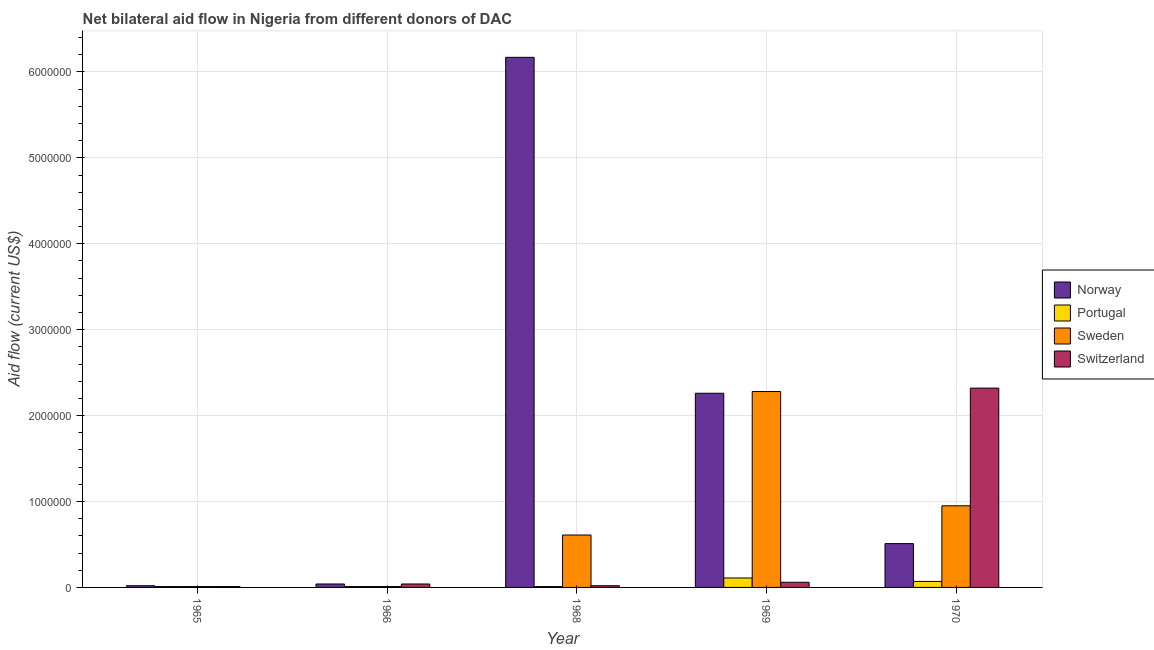How many groups of bars are there?
Your response must be concise. 5. How many bars are there on the 1st tick from the left?
Provide a succinct answer. 4. How many bars are there on the 4th tick from the right?
Provide a succinct answer. 4. What is the label of the 4th group of bars from the left?
Give a very brief answer. 1969. In how many cases, is the number of bars for a given year not equal to the number of legend labels?
Ensure brevity in your answer.  0. What is the amount of aid given by switzerland in 1970?
Provide a short and direct response. 2.32e+06. Across all years, what is the maximum amount of aid given by portugal?
Offer a very short reply. 1.10e+05. Across all years, what is the minimum amount of aid given by portugal?
Ensure brevity in your answer.  10000. In which year was the amount of aid given by sweden minimum?
Keep it short and to the point. 1965. What is the total amount of aid given by sweden in the graph?
Provide a short and direct response. 3.86e+06. What is the difference between the amount of aid given by switzerland in 1965 and that in 1966?
Keep it short and to the point. -3.00e+04. What is the difference between the amount of aid given by switzerland in 1969 and the amount of aid given by norway in 1968?
Your answer should be compact. 4.00e+04. In how many years, is the amount of aid given by sweden greater than 3600000 US$?
Offer a very short reply. 0. What is the difference between the highest and the second highest amount of aid given by sweden?
Your answer should be very brief. 1.33e+06. What is the difference between the highest and the lowest amount of aid given by portugal?
Keep it short and to the point. 1.00e+05. In how many years, is the amount of aid given by norway greater than the average amount of aid given by norway taken over all years?
Make the answer very short. 2. Is it the case that in every year, the sum of the amount of aid given by norway and amount of aid given by sweden is greater than the sum of amount of aid given by switzerland and amount of aid given by portugal?
Keep it short and to the point. Yes. What does the 1st bar from the left in 1965 represents?
Make the answer very short. Norway. What does the 3rd bar from the right in 1966 represents?
Ensure brevity in your answer.  Portugal. Is it the case that in every year, the sum of the amount of aid given by norway and amount of aid given by portugal is greater than the amount of aid given by sweden?
Ensure brevity in your answer.  No. How many bars are there?
Give a very brief answer. 20. Are all the bars in the graph horizontal?
Your response must be concise. No. Does the graph contain any zero values?
Your answer should be compact. No. Does the graph contain grids?
Provide a succinct answer. Yes. Where does the legend appear in the graph?
Offer a very short reply. Center right. How are the legend labels stacked?
Keep it short and to the point. Vertical. What is the title of the graph?
Your answer should be compact. Net bilateral aid flow in Nigeria from different donors of DAC. What is the label or title of the X-axis?
Your response must be concise. Year. What is the label or title of the Y-axis?
Give a very brief answer. Aid flow (current US$). What is the Aid flow (current US$) in Portugal in 1965?
Make the answer very short. 10000. What is the Aid flow (current US$) in Norway in 1966?
Offer a terse response. 4.00e+04. What is the Aid flow (current US$) of Portugal in 1966?
Your answer should be very brief. 10000. What is the Aid flow (current US$) of Sweden in 1966?
Ensure brevity in your answer.  10000. What is the Aid flow (current US$) in Switzerland in 1966?
Your response must be concise. 4.00e+04. What is the Aid flow (current US$) in Norway in 1968?
Offer a very short reply. 6.17e+06. What is the Aid flow (current US$) of Portugal in 1968?
Your answer should be compact. 10000. What is the Aid flow (current US$) of Sweden in 1968?
Make the answer very short. 6.10e+05. What is the Aid flow (current US$) of Switzerland in 1968?
Provide a succinct answer. 2.00e+04. What is the Aid flow (current US$) of Norway in 1969?
Give a very brief answer. 2.26e+06. What is the Aid flow (current US$) in Sweden in 1969?
Your response must be concise. 2.28e+06. What is the Aid flow (current US$) in Switzerland in 1969?
Your response must be concise. 6.00e+04. What is the Aid flow (current US$) in Norway in 1970?
Your response must be concise. 5.10e+05. What is the Aid flow (current US$) of Sweden in 1970?
Give a very brief answer. 9.50e+05. What is the Aid flow (current US$) in Switzerland in 1970?
Ensure brevity in your answer.  2.32e+06. Across all years, what is the maximum Aid flow (current US$) of Norway?
Your answer should be compact. 6.17e+06. Across all years, what is the maximum Aid flow (current US$) of Sweden?
Provide a short and direct response. 2.28e+06. Across all years, what is the maximum Aid flow (current US$) in Switzerland?
Your answer should be compact. 2.32e+06. Across all years, what is the minimum Aid flow (current US$) of Norway?
Your answer should be very brief. 2.00e+04. Across all years, what is the minimum Aid flow (current US$) in Portugal?
Offer a terse response. 10000. Across all years, what is the minimum Aid flow (current US$) in Sweden?
Provide a succinct answer. 10000. What is the total Aid flow (current US$) in Norway in the graph?
Your answer should be very brief. 9.00e+06. What is the total Aid flow (current US$) of Sweden in the graph?
Make the answer very short. 3.86e+06. What is the total Aid flow (current US$) in Switzerland in the graph?
Ensure brevity in your answer.  2.45e+06. What is the difference between the Aid flow (current US$) of Portugal in 1965 and that in 1966?
Keep it short and to the point. 0. What is the difference between the Aid flow (current US$) in Sweden in 1965 and that in 1966?
Your answer should be very brief. 0. What is the difference between the Aid flow (current US$) of Norway in 1965 and that in 1968?
Your response must be concise. -6.15e+06. What is the difference between the Aid flow (current US$) in Portugal in 1965 and that in 1968?
Offer a very short reply. 0. What is the difference between the Aid flow (current US$) in Sweden in 1965 and that in 1968?
Offer a terse response. -6.00e+05. What is the difference between the Aid flow (current US$) in Norway in 1965 and that in 1969?
Offer a terse response. -2.24e+06. What is the difference between the Aid flow (current US$) of Sweden in 1965 and that in 1969?
Your response must be concise. -2.27e+06. What is the difference between the Aid flow (current US$) of Norway in 1965 and that in 1970?
Ensure brevity in your answer.  -4.90e+05. What is the difference between the Aid flow (current US$) of Sweden in 1965 and that in 1970?
Your response must be concise. -9.40e+05. What is the difference between the Aid flow (current US$) of Switzerland in 1965 and that in 1970?
Ensure brevity in your answer.  -2.31e+06. What is the difference between the Aid flow (current US$) of Norway in 1966 and that in 1968?
Offer a very short reply. -6.13e+06. What is the difference between the Aid flow (current US$) of Sweden in 1966 and that in 1968?
Your answer should be very brief. -6.00e+05. What is the difference between the Aid flow (current US$) in Switzerland in 1966 and that in 1968?
Your answer should be very brief. 2.00e+04. What is the difference between the Aid flow (current US$) of Norway in 1966 and that in 1969?
Offer a terse response. -2.22e+06. What is the difference between the Aid flow (current US$) in Sweden in 1966 and that in 1969?
Provide a succinct answer. -2.27e+06. What is the difference between the Aid flow (current US$) in Switzerland in 1966 and that in 1969?
Keep it short and to the point. -2.00e+04. What is the difference between the Aid flow (current US$) in Norway in 1966 and that in 1970?
Make the answer very short. -4.70e+05. What is the difference between the Aid flow (current US$) of Portugal in 1966 and that in 1970?
Your answer should be very brief. -6.00e+04. What is the difference between the Aid flow (current US$) in Sweden in 1966 and that in 1970?
Keep it short and to the point. -9.40e+05. What is the difference between the Aid flow (current US$) in Switzerland in 1966 and that in 1970?
Make the answer very short. -2.28e+06. What is the difference between the Aid flow (current US$) of Norway in 1968 and that in 1969?
Make the answer very short. 3.91e+06. What is the difference between the Aid flow (current US$) in Sweden in 1968 and that in 1969?
Make the answer very short. -1.67e+06. What is the difference between the Aid flow (current US$) of Norway in 1968 and that in 1970?
Make the answer very short. 5.66e+06. What is the difference between the Aid flow (current US$) of Portugal in 1968 and that in 1970?
Make the answer very short. -6.00e+04. What is the difference between the Aid flow (current US$) of Sweden in 1968 and that in 1970?
Give a very brief answer. -3.40e+05. What is the difference between the Aid flow (current US$) in Switzerland in 1968 and that in 1970?
Give a very brief answer. -2.30e+06. What is the difference between the Aid flow (current US$) of Norway in 1969 and that in 1970?
Offer a very short reply. 1.75e+06. What is the difference between the Aid flow (current US$) in Sweden in 1969 and that in 1970?
Ensure brevity in your answer.  1.33e+06. What is the difference between the Aid flow (current US$) in Switzerland in 1969 and that in 1970?
Offer a very short reply. -2.26e+06. What is the difference between the Aid flow (current US$) in Norway in 1965 and the Aid flow (current US$) in Portugal in 1966?
Keep it short and to the point. 10000. What is the difference between the Aid flow (current US$) of Portugal in 1965 and the Aid flow (current US$) of Sweden in 1966?
Your response must be concise. 0. What is the difference between the Aid flow (current US$) of Sweden in 1965 and the Aid flow (current US$) of Switzerland in 1966?
Your answer should be very brief. -3.00e+04. What is the difference between the Aid flow (current US$) in Norway in 1965 and the Aid flow (current US$) in Portugal in 1968?
Your answer should be very brief. 10000. What is the difference between the Aid flow (current US$) in Norway in 1965 and the Aid flow (current US$) in Sweden in 1968?
Your answer should be very brief. -5.90e+05. What is the difference between the Aid flow (current US$) of Norway in 1965 and the Aid flow (current US$) of Switzerland in 1968?
Provide a succinct answer. 0. What is the difference between the Aid flow (current US$) of Portugal in 1965 and the Aid flow (current US$) of Sweden in 1968?
Keep it short and to the point. -6.00e+05. What is the difference between the Aid flow (current US$) of Norway in 1965 and the Aid flow (current US$) of Portugal in 1969?
Your answer should be very brief. -9.00e+04. What is the difference between the Aid flow (current US$) in Norway in 1965 and the Aid flow (current US$) in Sweden in 1969?
Make the answer very short. -2.26e+06. What is the difference between the Aid flow (current US$) in Norway in 1965 and the Aid flow (current US$) in Switzerland in 1969?
Your answer should be very brief. -4.00e+04. What is the difference between the Aid flow (current US$) in Portugal in 1965 and the Aid flow (current US$) in Sweden in 1969?
Your answer should be very brief. -2.27e+06. What is the difference between the Aid flow (current US$) of Sweden in 1965 and the Aid flow (current US$) of Switzerland in 1969?
Provide a short and direct response. -5.00e+04. What is the difference between the Aid flow (current US$) in Norway in 1965 and the Aid flow (current US$) in Portugal in 1970?
Your answer should be very brief. -5.00e+04. What is the difference between the Aid flow (current US$) in Norway in 1965 and the Aid flow (current US$) in Sweden in 1970?
Your answer should be very brief. -9.30e+05. What is the difference between the Aid flow (current US$) in Norway in 1965 and the Aid flow (current US$) in Switzerland in 1970?
Give a very brief answer. -2.30e+06. What is the difference between the Aid flow (current US$) in Portugal in 1965 and the Aid flow (current US$) in Sweden in 1970?
Keep it short and to the point. -9.40e+05. What is the difference between the Aid flow (current US$) of Portugal in 1965 and the Aid flow (current US$) of Switzerland in 1970?
Offer a very short reply. -2.31e+06. What is the difference between the Aid flow (current US$) of Sweden in 1965 and the Aid flow (current US$) of Switzerland in 1970?
Ensure brevity in your answer.  -2.31e+06. What is the difference between the Aid flow (current US$) of Norway in 1966 and the Aid flow (current US$) of Sweden in 1968?
Provide a short and direct response. -5.70e+05. What is the difference between the Aid flow (current US$) of Portugal in 1966 and the Aid flow (current US$) of Sweden in 1968?
Provide a short and direct response. -6.00e+05. What is the difference between the Aid flow (current US$) of Sweden in 1966 and the Aid flow (current US$) of Switzerland in 1968?
Provide a succinct answer. -10000. What is the difference between the Aid flow (current US$) in Norway in 1966 and the Aid flow (current US$) in Sweden in 1969?
Provide a short and direct response. -2.24e+06. What is the difference between the Aid flow (current US$) in Portugal in 1966 and the Aid flow (current US$) in Sweden in 1969?
Make the answer very short. -2.27e+06. What is the difference between the Aid flow (current US$) in Sweden in 1966 and the Aid flow (current US$) in Switzerland in 1969?
Your response must be concise. -5.00e+04. What is the difference between the Aid flow (current US$) in Norway in 1966 and the Aid flow (current US$) in Portugal in 1970?
Offer a very short reply. -3.00e+04. What is the difference between the Aid flow (current US$) in Norway in 1966 and the Aid flow (current US$) in Sweden in 1970?
Offer a very short reply. -9.10e+05. What is the difference between the Aid flow (current US$) in Norway in 1966 and the Aid flow (current US$) in Switzerland in 1970?
Make the answer very short. -2.28e+06. What is the difference between the Aid flow (current US$) in Portugal in 1966 and the Aid flow (current US$) in Sweden in 1970?
Offer a terse response. -9.40e+05. What is the difference between the Aid flow (current US$) in Portugal in 1966 and the Aid flow (current US$) in Switzerland in 1970?
Keep it short and to the point. -2.31e+06. What is the difference between the Aid flow (current US$) of Sweden in 1966 and the Aid flow (current US$) of Switzerland in 1970?
Your answer should be very brief. -2.31e+06. What is the difference between the Aid flow (current US$) in Norway in 1968 and the Aid flow (current US$) in Portugal in 1969?
Offer a very short reply. 6.06e+06. What is the difference between the Aid flow (current US$) in Norway in 1968 and the Aid flow (current US$) in Sweden in 1969?
Your answer should be compact. 3.89e+06. What is the difference between the Aid flow (current US$) of Norway in 1968 and the Aid flow (current US$) of Switzerland in 1969?
Provide a short and direct response. 6.11e+06. What is the difference between the Aid flow (current US$) of Portugal in 1968 and the Aid flow (current US$) of Sweden in 1969?
Your answer should be very brief. -2.27e+06. What is the difference between the Aid flow (current US$) in Portugal in 1968 and the Aid flow (current US$) in Switzerland in 1969?
Offer a very short reply. -5.00e+04. What is the difference between the Aid flow (current US$) of Sweden in 1968 and the Aid flow (current US$) of Switzerland in 1969?
Give a very brief answer. 5.50e+05. What is the difference between the Aid flow (current US$) of Norway in 1968 and the Aid flow (current US$) of Portugal in 1970?
Your response must be concise. 6.10e+06. What is the difference between the Aid flow (current US$) in Norway in 1968 and the Aid flow (current US$) in Sweden in 1970?
Your answer should be compact. 5.22e+06. What is the difference between the Aid flow (current US$) of Norway in 1968 and the Aid flow (current US$) of Switzerland in 1970?
Keep it short and to the point. 3.85e+06. What is the difference between the Aid flow (current US$) in Portugal in 1968 and the Aid flow (current US$) in Sweden in 1970?
Your answer should be very brief. -9.40e+05. What is the difference between the Aid flow (current US$) of Portugal in 1968 and the Aid flow (current US$) of Switzerland in 1970?
Your answer should be compact. -2.31e+06. What is the difference between the Aid flow (current US$) of Sweden in 1968 and the Aid flow (current US$) of Switzerland in 1970?
Give a very brief answer. -1.71e+06. What is the difference between the Aid flow (current US$) of Norway in 1969 and the Aid flow (current US$) of Portugal in 1970?
Make the answer very short. 2.19e+06. What is the difference between the Aid flow (current US$) in Norway in 1969 and the Aid flow (current US$) in Sweden in 1970?
Provide a short and direct response. 1.31e+06. What is the difference between the Aid flow (current US$) of Norway in 1969 and the Aid flow (current US$) of Switzerland in 1970?
Provide a succinct answer. -6.00e+04. What is the difference between the Aid flow (current US$) in Portugal in 1969 and the Aid flow (current US$) in Sweden in 1970?
Give a very brief answer. -8.40e+05. What is the difference between the Aid flow (current US$) of Portugal in 1969 and the Aid flow (current US$) of Switzerland in 1970?
Your answer should be very brief. -2.21e+06. What is the average Aid flow (current US$) in Norway per year?
Your response must be concise. 1.80e+06. What is the average Aid flow (current US$) in Portugal per year?
Your answer should be compact. 4.20e+04. What is the average Aid flow (current US$) of Sweden per year?
Provide a succinct answer. 7.72e+05. In the year 1965, what is the difference between the Aid flow (current US$) of Norway and Aid flow (current US$) of Sweden?
Provide a succinct answer. 10000. In the year 1965, what is the difference between the Aid flow (current US$) in Portugal and Aid flow (current US$) in Sweden?
Your answer should be very brief. 0. In the year 1965, what is the difference between the Aid flow (current US$) in Sweden and Aid flow (current US$) in Switzerland?
Your response must be concise. 0. In the year 1966, what is the difference between the Aid flow (current US$) of Norway and Aid flow (current US$) of Portugal?
Your response must be concise. 3.00e+04. In the year 1966, what is the difference between the Aid flow (current US$) of Norway and Aid flow (current US$) of Sweden?
Give a very brief answer. 3.00e+04. In the year 1966, what is the difference between the Aid flow (current US$) of Sweden and Aid flow (current US$) of Switzerland?
Your answer should be compact. -3.00e+04. In the year 1968, what is the difference between the Aid flow (current US$) in Norway and Aid flow (current US$) in Portugal?
Offer a very short reply. 6.16e+06. In the year 1968, what is the difference between the Aid flow (current US$) in Norway and Aid flow (current US$) in Sweden?
Your answer should be compact. 5.56e+06. In the year 1968, what is the difference between the Aid flow (current US$) of Norway and Aid flow (current US$) of Switzerland?
Offer a terse response. 6.15e+06. In the year 1968, what is the difference between the Aid flow (current US$) of Portugal and Aid flow (current US$) of Sweden?
Make the answer very short. -6.00e+05. In the year 1968, what is the difference between the Aid flow (current US$) in Sweden and Aid flow (current US$) in Switzerland?
Make the answer very short. 5.90e+05. In the year 1969, what is the difference between the Aid flow (current US$) of Norway and Aid flow (current US$) of Portugal?
Provide a succinct answer. 2.15e+06. In the year 1969, what is the difference between the Aid flow (current US$) of Norway and Aid flow (current US$) of Sweden?
Offer a very short reply. -2.00e+04. In the year 1969, what is the difference between the Aid flow (current US$) in Norway and Aid flow (current US$) in Switzerland?
Make the answer very short. 2.20e+06. In the year 1969, what is the difference between the Aid flow (current US$) of Portugal and Aid flow (current US$) of Sweden?
Provide a short and direct response. -2.17e+06. In the year 1969, what is the difference between the Aid flow (current US$) in Portugal and Aid flow (current US$) in Switzerland?
Offer a terse response. 5.00e+04. In the year 1969, what is the difference between the Aid flow (current US$) in Sweden and Aid flow (current US$) in Switzerland?
Provide a short and direct response. 2.22e+06. In the year 1970, what is the difference between the Aid flow (current US$) in Norway and Aid flow (current US$) in Portugal?
Your response must be concise. 4.40e+05. In the year 1970, what is the difference between the Aid flow (current US$) of Norway and Aid flow (current US$) of Sweden?
Offer a very short reply. -4.40e+05. In the year 1970, what is the difference between the Aid flow (current US$) in Norway and Aid flow (current US$) in Switzerland?
Offer a very short reply. -1.81e+06. In the year 1970, what is the difference between the Aid flow (current US$) of Portugal and Aid flow (current US$) of Sweden?
Provide a succinct answer. -8.80e+05. In the year 1970, what is the difference between the Aid flow (current US$) in Portugal and Aid flow (current US$) in Switzerland?
Provide a succinct answer. -2.25e+06. In the year 1970, what is the difference between the Aid flow (current US$) in Sweden and Aid flow (current US$) in Switzerland?
Offer a terse response. -1.37e+06. What is the ratio of the Aid flow (current US$) of Portugal in 1965 to that in 1966?
Give a very brief answer. 1. What is the ratio of the Aid flow (current US$) of Sweden in 1965 to that in 1966?
Make the answer very short. 1. What is the ratio of the Aid flow (current US$) in Switzerland in 1965 to that in 1966?
Your answer should be compact. 0.25. What is the ratio of the Aid flow (current US$) in Norway in 1965 to that in 1968?
Ensure brevity in your answer.  0. What is the ratio of the Aid flow (current US$) in Portugal in 1965 to that in 1968?
Give a very brief answer. 1. What is the ratio of the Aid flow (current US$) of Sweden in 1965 to that in 1968?
Offer a very short reply. 0.02. What is the ratio of the Aid flow (current US$) of Switzerland in 1965 to that in 1968?
Provide a short and direct response. 0.5. What is the ratio of the Aid flow (current US$) in Norway in 1965 to that in 1969?
Offer a very short reply. 0.01. What is the ratio of the Aid flow (current US$) in Portugal in 1965 to that in 1969?
Your response must be concise. 0.09. What is the ratio of the Aid flow (current US$) in Sweden in 1965 to that in 1969?
Offer a terse response. 0. What is the ratio of the Aid flow (current US$) in Switzerland in 1965 to that in 1969?
Your answer should be compact. 0.17. What is the ratio of the Aid flow (current US$) of Norway in 1965 to that in 1970?
Make the answer very short. 0.04. What is the ratio of the Aid flow (current US$) in Portugal in 1965 to that in 1970?
Keep it short and to the point. 0.14. What is the ratio of the Aid flow (current US$) of Sweden in 1965 to that in 1970?
Offer a terse response. 0.01. What is the ratio of the Aid flow (current US$) in Switzerland in 1965 to that in 1970?
Keep it short and to the point. 0. What is the ratio of the Aid flow (current US$) of Norway in 1966 to that in 1968?
Your answer should be very brief. 0.01. What is the ratio of the Aid flow (current US$) of Sweden in 1966 to that in 1968?
Your response must be concise. 0.02. What is the ratio of the Aid flow (current US$) of Norway in 1966 to that in 1969?
Keep it short and to the point. 0.02. What is the ratio of the Aid flow (current US$) in Portugal in 1966 to that in 1969?
Keep it short and to the point. 0.09. What is the ratio of the Aid flow (current US$) of Sweden in 1966 to that in 1969?
Your response must be concise. 0. What is the ratio of the Aid flow (current US$) in Norway in 1966 to that in 1970?
Your response must be concise. 0.08. What is the ratio of the Aid flow (current US$) of Portugal in 1966 to that in 1970?
Your answer should be very brief. 0.14. What is the ratio of the Aid flow (current US$) in Sweden in 1966 to that in 1970?
Give a very brief answer. 0.01. What is the ratio of the Aid flow (current US$) of Switzerland in 1966 to that in 1970?
Offer a terse response. 0.02. What is the ratio of the Aid flow (current US$) in Norway in 1968 to that in 1969?
Offer a very short reply. 2.73. What is the ratio of the Aid flow (current US$) of Portugal in 1968 to that in 1969?
Your response must be concise. 0.09. What is the ratio of the Aid flow (current US$) in Sweden in 1968 to that in 1969?
Give a very brief answer. 0.27. What is the ratio of the Aid flow (current US$) in Norway in 1968 to that in 1970?
Offer a terse response. 12.1. What is the ratio of the Aid flow (current US$) in Portugal in 1968 to that in 1970?
Offer a very short reply. 0.14. What is the ratio of the Aid flow (current US$) in Sweden in 1968 to that in 1970?
Your answer should be very brief. 0.64. What is the ratio of the Aid flow (current US$) of Switzerland in 1968 to that in 1970?
Provide a succinct answer. 0.01. What is the ratio of the Aid flow (current US$) in Norway in 1969 to that in 1970?
Provide a succinct answer. 4.43. What is the ratio of the Aid flow (current US$) in Portugal in 1969 to that in 1970?
Your answer should be very brief. 1.57. What is the ratio of the Aid flow (current US$) of Sweden in 1969 to that in 1970?
Keep it short and to the point. 2.4. What is the ratio of the Aid flow (current US$) of Switzerland in 1969 to that in 1970?
Provide a succinct answer. 0.03. What is the difference between the highest and the second highest Aid flow (current US$) of Norway?
Give a very brief answer. 3.91e+06. What is the difference between the highest and the second highest Aid flow (current US$) of Portugal?
Offer a very short reply. 4.00e+04. What is the difference between the highest and the second highest Aid flow (current US$) in Sweden?
Your answer should be very brief. 1.33e+06. What is the difference between the highest and the second highest Aid flow (current US$) in Switzerland?
Keep it short and to the point. 2.26e+06. What is the difference between the highest and the lowest Aid flow (current US$) of Norway?
Your response must be concise. 6.15e+06. What is the difference between the highest and the lowest Aid flow (current US$) of Sweden?
Offer a very short reply. 2.27e+06. What is the difference between the highest and the lowest Aid flow (current US$) in Switzerland?
Give a very brief answer. 2.31e+06. 